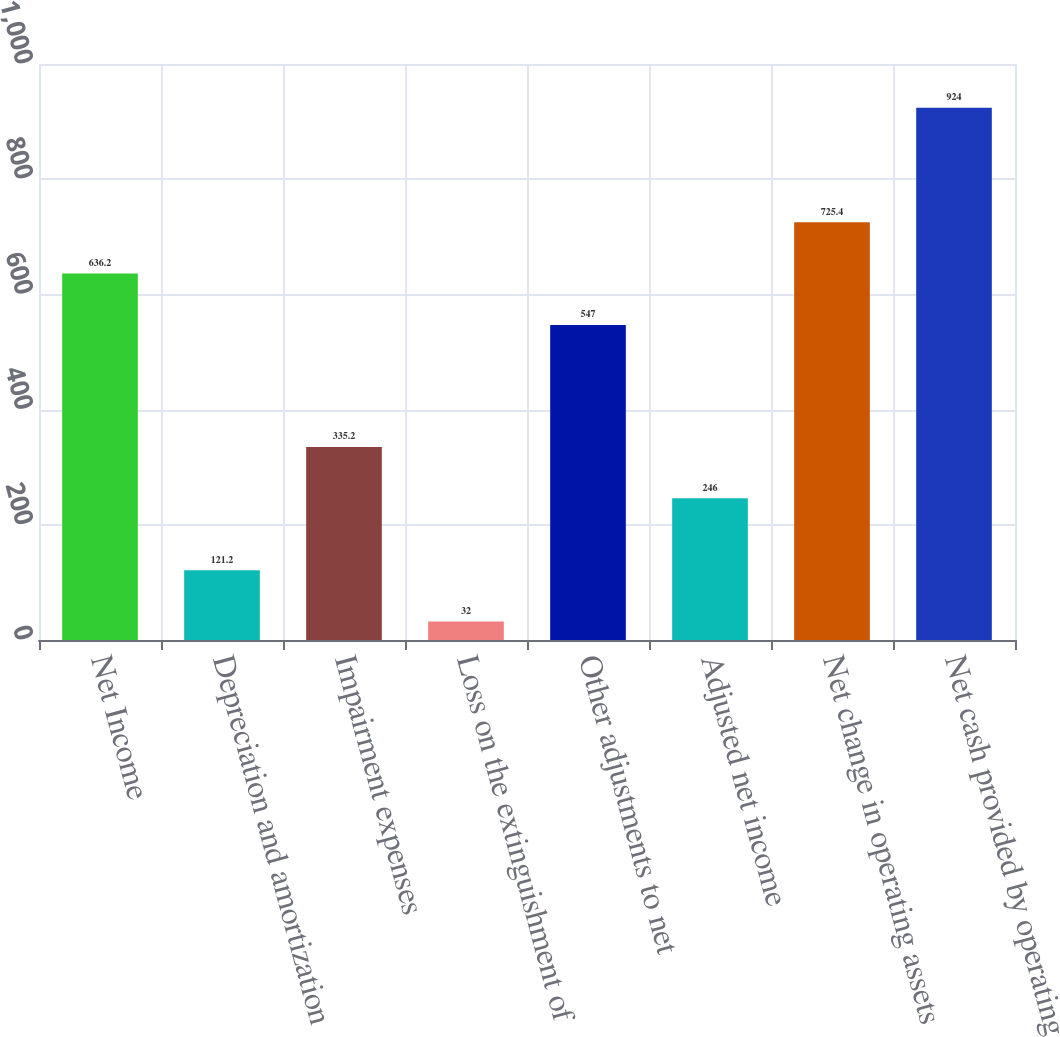Convert chart. <chart><loc_0><loc_0><loc_500><loc_500><bar_chart><fcel>Net Income<fcel>Depreciation and amortization<fcel>Impairment expenses<fcel>Loss on the extinguishment of<fcel>Other adjustments to net<fcel>Adjusted net income<fcel>Net change in operating assets<fcel>Net cash provided by operating<nl><fcel>636.2<fcel>121.2<fcel>335.2<fcel>32<fcel>547<fcel>246<fcel>725.4<fcel>924<nl></chart> 